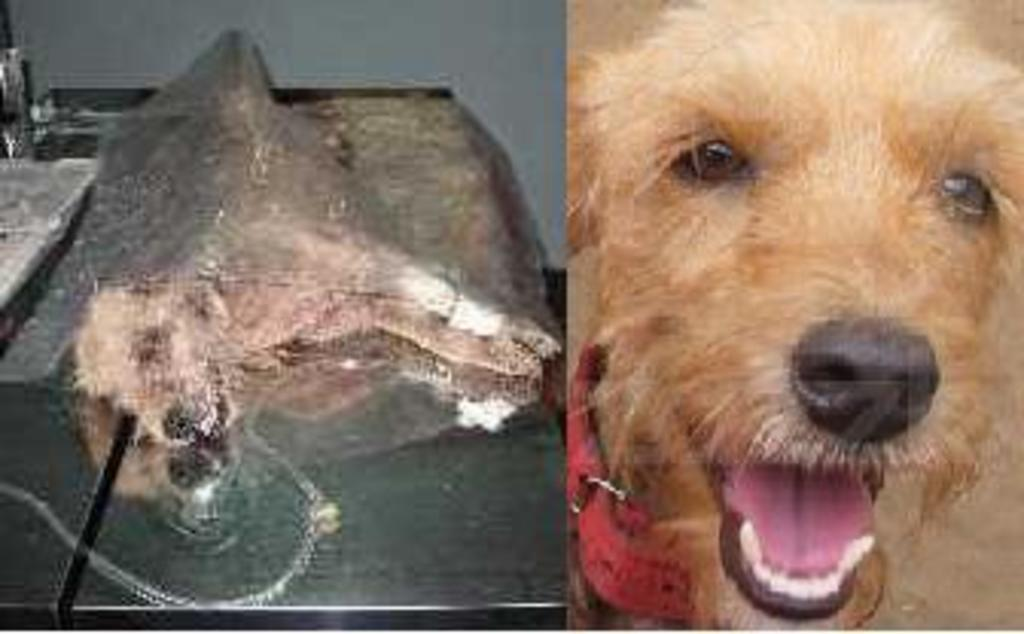What type of artwork is shown in the image? The image is a collage. What is depicted in the first part of the collage? The first part of the collage shows the full picture of a dog. What is depicted in the second part of the collage? The second part of the collage shows only the face part of the dog. Where is the basin located in the image? There is no basin present in the image; it is a collage featuring a dog. What is the nature of the argument between the dog and the cat in the image? There is no cat present in the image, and no argument is depicted. 